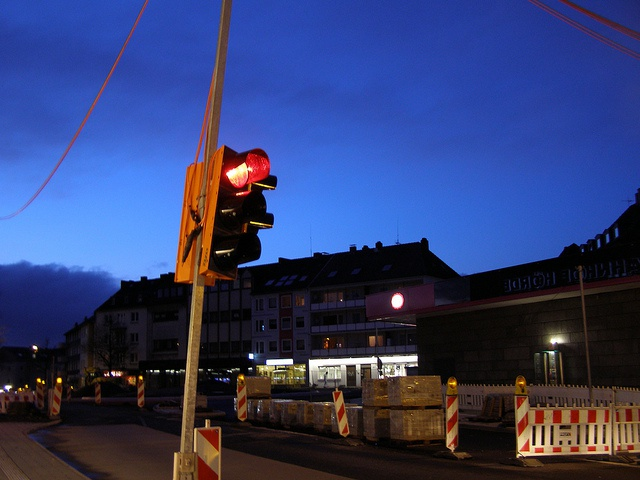Describe the objects in this image and their specific colors. I can see a traffic light in blue, black, red, and maroon tones in this image. 